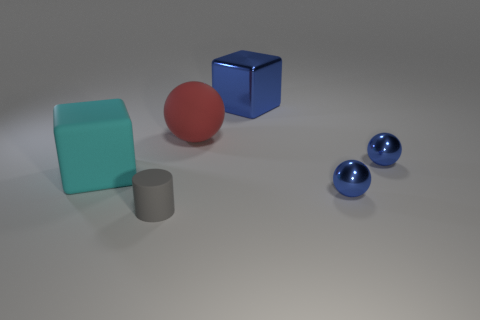Add 1 red things. How many objects exist? 7 Subtract all cubes. How many objects are left? 4 Add 2 big rubber objects. How many big rubber objects are left? 4 Add 1 cyan things. How many cyan things exist? 2 Subtract 0 cyan balls. How many objects are left? 6 Subtract all red matte objects. Subtract all small matte cylinders. How many objects are left? 4 